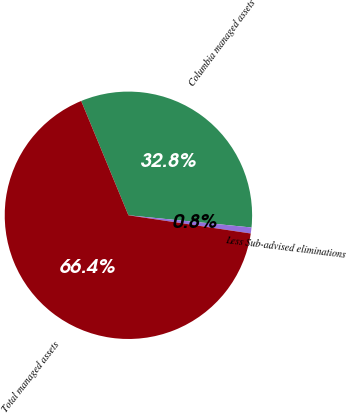Convert chart to OTSL. <chart><loc_0><loc_0><loc_500><loc_500><pie_chart><fcel>Columbia managed assets<fcel>Less Sub-advised eliminations<fcel>Total managed assets<nl><fcel>32.81%<fcel>0.78%<fcel>66.41%<nl></chart> 